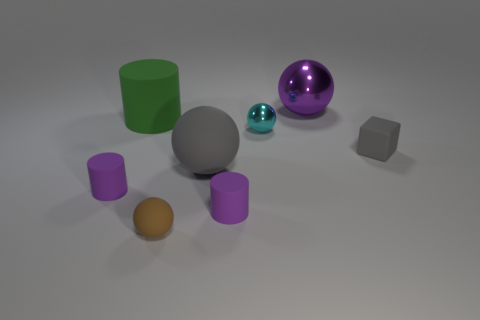What is the shape of the tiny gray thing that is made of the same material as the big green thing?
Your response must be concise. Cube. There is a tiny object on the right side of the sphere to the right of the cyan shiny thing; what is its material?
Ensure brevity in your answer.  Rubber. There is a large object that is in front of the gray block; is its shape the same as the big purple object?
Your answer should be very brief. Yes. Are there more tiny matte objects left of the purple shiny thing than large cyan spheres?
Provide a succinct answer. Yes. There is a big thing that is the same color as the block; what shape is it?
Provide a short and direct response. Sphere. What number of cylinders are either tiny purple matte objects or tiny shiny things?
Your answer should be compact. 2. There is a cylinder that is behind the tiny rubber cube that is in front of the big matte cylinder; what color is it?
Provide a succinct answer. Green. Is the color of the big shiny sphere the same as the small matte cylinder that is on the right side of the large cylinder?
Keep it short and to the point. Yes. What size is the gray cube that is made of the same material as the large green thing?
Offer a terse response. Small. There is a object that is the same color as the small rubber cube; what is its size?
Ensure brevity in your answer.  Large. 